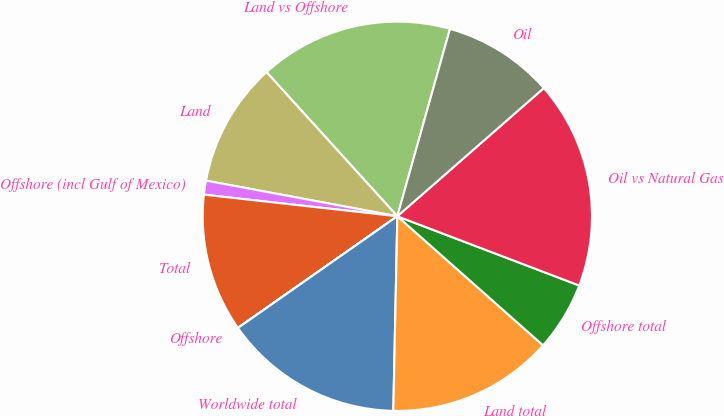Convert chart to OTSL. <chart><loc_0><loc_0><loc_500><loc_500><pie_chart><fcel>Land vs Offshore<fcel>Land<fcel>Offshore (incl Gulf of Mexico)<fcel>Total<fcel>Offshore<fcel>Worldwide total<fcel>Land total<fcel>Offshore total<fcel>Oil vs Natural Gas<fcel>Oil<nl><fcel>16.09%<fcel>10.34%<fcel>1.16%<fcel>11.49%<fcel>0.01%<fcel>14.94%<fcel>13.79%<fcel>5.75%<fcel>17.23%<fcel>9.2%<nl></chart> 